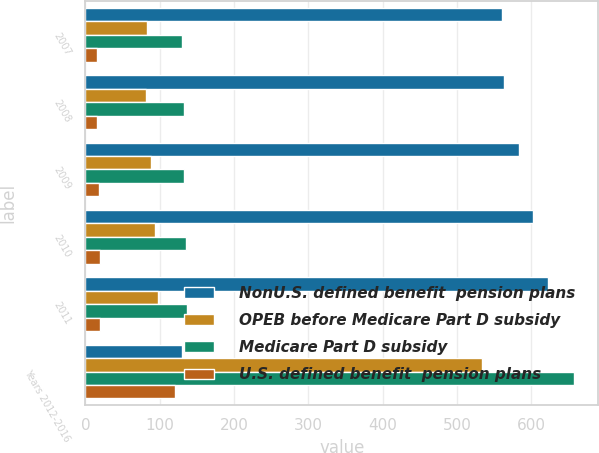Convert chart. <chart><loc_0><loc_0><loc_500><loc_500><stacked_bar_chart><ecel><fcel>2007<fcel>2008<fcel>2009<fcel>2010<fcel>2011<fcel>Years 2012-2016<nl><fcel>NonU.S. defined benefit  pension plans<fcel>561<fcel>563<fcel>583<fcel>602<fcel>623<fcel>130<nl><fcel>OPEB before Medicare Part D subsidy<fcel>83<fcel>81<fcel>88<fcel>93<fcel>97<fcel>533<nl><fcel>Medicare Part D subsidy<fcel>130<fcel>132<fcel>133<fcel>135<fcel>137<fcel>657<nl><fcel>U.S. defined benefit  pension plans<fcel>15<fcel>16<fcel>18<fcel>19<fcel>20<fcel>121<nl></chart> 